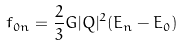Convert formula to latex. <formula><loc_0><loc_0><loc_500><loc_500>f _ { 0 n } = \frac { 2 } { 3 } G | Q | ^ { 2 } ( E _ { n } - E _ { 0 } )</formula> 